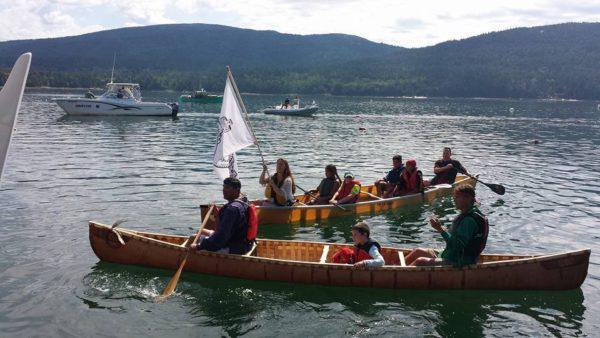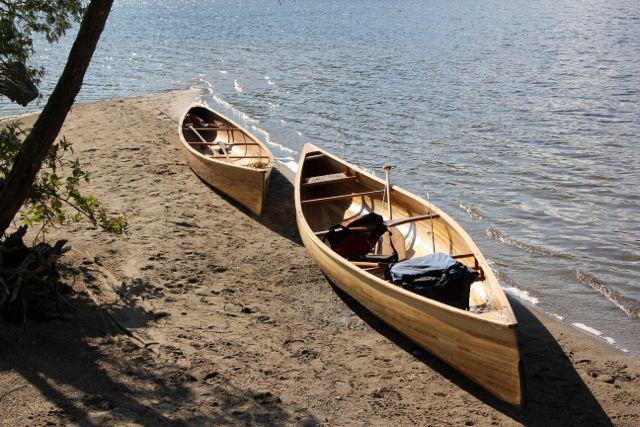The first image is the image on the left, the second image is the image on the right. Examine the images to the left and right. Is the description "An image shows one watercraft made of three floating red parts joined on top by a rectangular shape." accurate? Answer yes or no. No. The first image is the image on the left, the second image is the image on the right. For the images displayed, is the sentence "The right hand image shows a flotation device with multiple red spears on the bottom and a flat plank-like object resting across the spears." factually correct? Answer yes or no. No. 